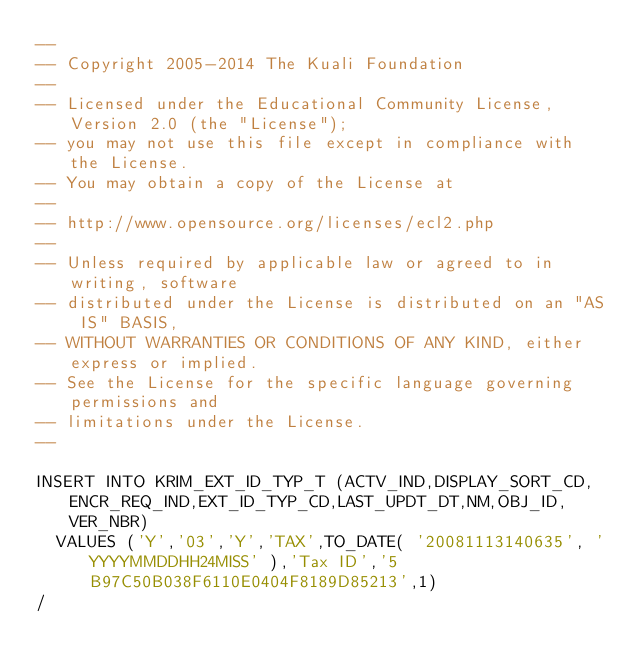<code> <loc_0><loc_0><loc_500><loc_500><_SQL_>--
-- Copyright 2005-2014 The Kuali Foundation
--
-- Licensed under the Educational Community License, Version 2.0 (the "License");
-- you may not use this file except in compliance with the License.
-- You may obtain a copy of the License at
--
-- http://www.opensource.org/licenses/ecl2.php
--
-- Unless required by applicable law or agreed to in writing, software
-- distributed under the License is distributed on an "AS IS" BASIS,
-- WITHOUT WARRANTIES OR CONDITIONS OF ANY KIND, either express or implied.
-- See the License for the specific language governing permissions and
-- limitations under the License.
--

INSERT INTO KRIM_EXT_ID_TYP_T (ACTV_IND,DISPLAY_SORT_CD,ENCR_REQ_IND,EXT_ID_TYP_CD,LAST_UPDT_DT,NM,OBJ_ID,VER_NBR)
  VALUES ('Y','03','Y','TAX',TO_DATE( '20081113140635', 'YYYYMMDDHH24MISS' ),'Tax ID','5B97C50B038F6110E0404F8189D85213',1)
/
</code> 